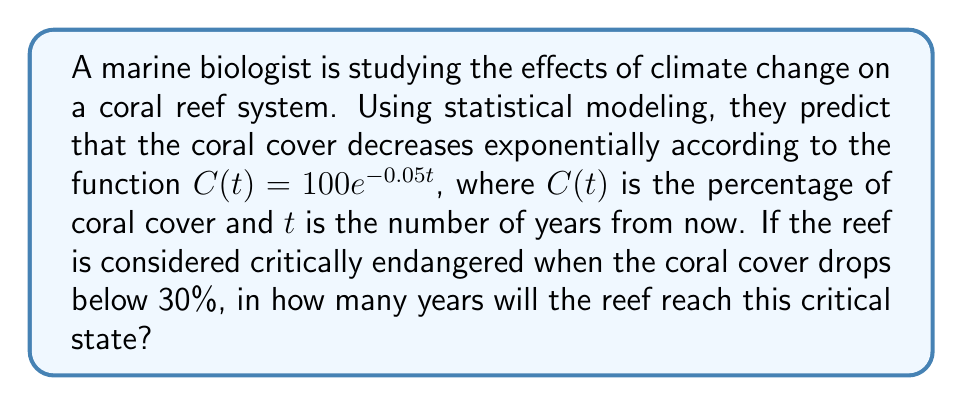Could you help me with this problem? To solve this problem, we need to follow these steps:

1. Identify the given information:
   - The coral cover function is $C(t) = 100e^{-0.05t}$
   - The critical threshold is 30% coral cover

2. Set up an equation to solve for t when C(t) = 30:
   $30 = 100e^{-0.05t}$

3. Divide both sides by 100:
   $0.3 = e^{-0.05t}$

4. Take the natural logarithm of both sides:
   $\ln(0.3) = \ln(e^{-0.05t})$

5. Simplify the right side using the properties of logarithms:
   $\ln(0.3) = -0.05t$

6. Solve for t:
   $t = -\frac{\ln(0.3)}{0.05}$

7. Calculate the result:
   $t = -\frac{\ln(0.3)}{0.05} \approx 24.08$ years

8. Round up to the nearest whole year, as we're dealing with discrete years:
   $t = 25$ years
Answer: 25 years 